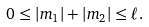Convert formula to latex. <formula><loc_0><loc_0><loc_500><loc_500>0 \leq \left | m _ { 1 } \right | + \left | m _ { 2 } \right | \leq \ell .</formula> 